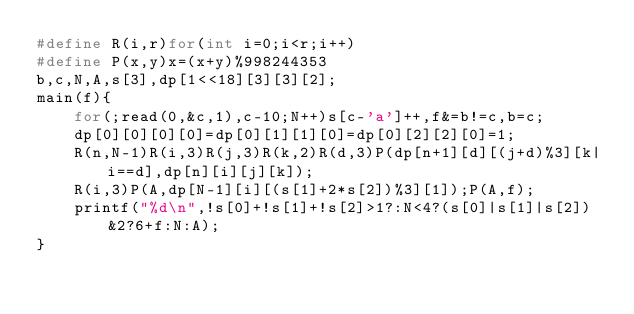Convert code to text. <code><loc_0><loc_0><loc_500><loc_500><_C_>#define R(i,r)for(int i=0;i<r;i++)
#define P(x,y)x=(x+y)%998244353
b,c,N,A,s[3],dp[1<<18][3][3][2];
main(f){
	for(;read(0,&c,1),c-10;N++)s[c-'a']++,f&=b!=c,b=c;
	dp[0][0][0][0]=dp[0][1][1][0]=dp[0][2][2][0]=1;
	R(n,N-1)R(i,3)R(j,3)R(k,2)R(d,3)P(dp[n+1][d][(j+d)%3][k|i==d],dp[n][i][j][k]);
	R(i,3)P(A,dp[N-1][i][(s[1]+2*s[2])%3][1]);P(A,f);
	printf("%d\n",!s[0]+!s[1]+!s[2]>1?:N<4?(s[0]|s[1]|s[2])&2?6+f:N:A);
}</code> 